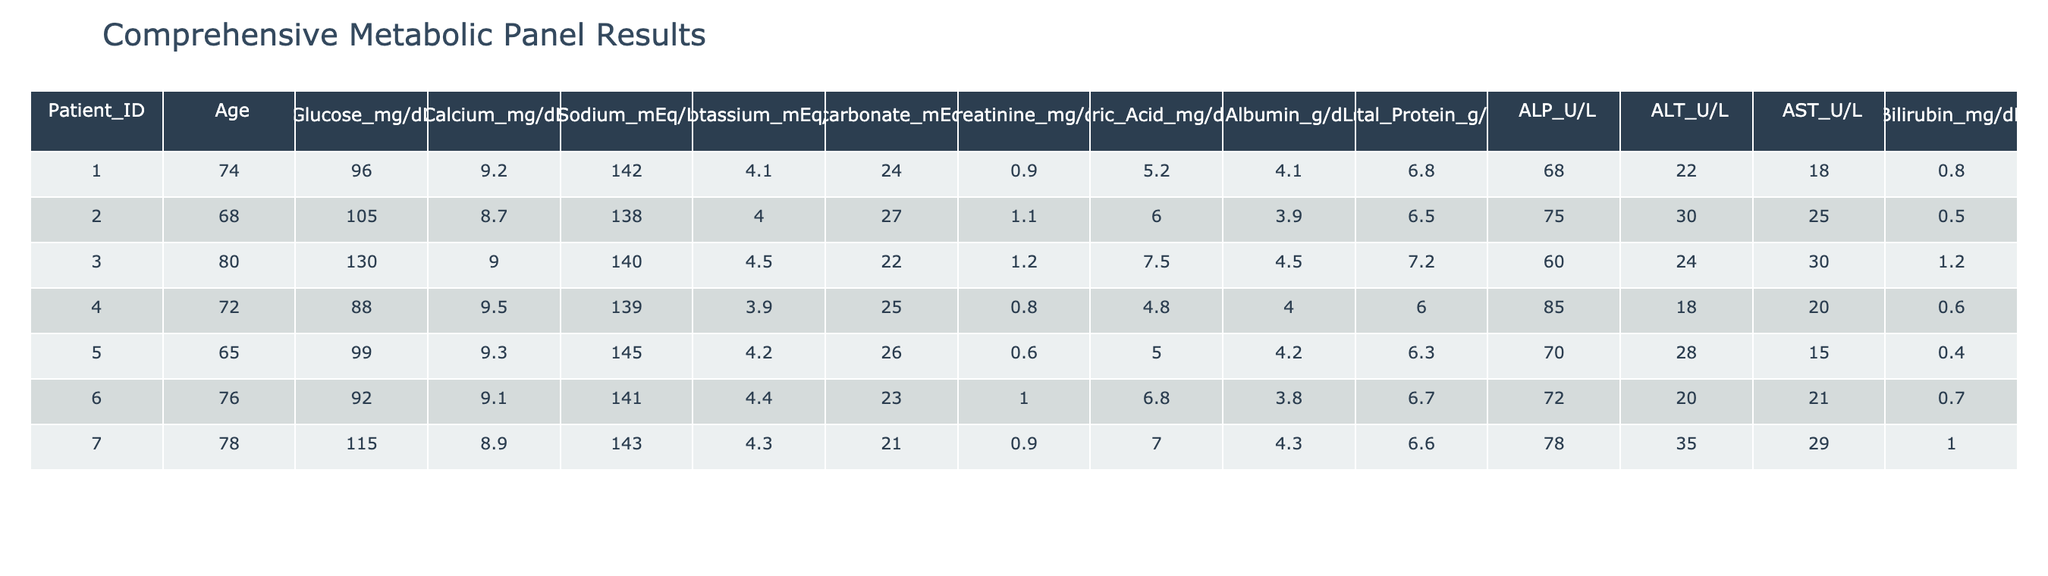What is the glucose level of patient ID 003? By looking at the row corresponding to patient ID 003, we see that the glucose level is listed under the Glucose_mg/dL column. The value there is 130.
Answer: 130 What is the age of the oldest patient in the table? First, we look at the Age column and identify the maximum age by scanning through the values. The highest value is 80, which belongs to patient ID 003.
Answer: 80 Are there any patients with a potassium level greater than 4.5 mEq/L? We need to check the Potassium_mEq/L column for values exceeding 4.5. Scanning through the data, patients ID 007 (4.3) and ID 003 (4.5) do not exceed this value. Therefore, there are no patients with potassium levels greater than 4.5.
Answer: No What is the average creatinine level for the patients listed? We sum the creatinine values (0.9 + 1.1 + 1.2 + 0.8 + 0.6 + 0.9 + 1.0) = 6.5. There are 7 patients, so we divide 6.5 by 7 to get the average. The calculation results in approximately 0.93.
Answer: 0.93 Which patient has the highest total protein level? We will check the Total_Protein_g/dL column for the highest value. Scanning the values, we find patient ID 001 has 6.8, and patient ID 002 has 6.5. The highest total protein level is 6.8, from patient ID 001.
Answer: 6.8 What is the difference in bilirubin levels between the highest and lowest in the table? We first identify the maximum (1.2 from patient ID 003) and minimum (0.4 from patient ID 005) bilirubin levels from the Bilirubin_mg/dL column. Their difference is 1.2 - 0.4 = 0.8.
Answer: 0.8 How many patients have an albumin level below 4 g/dL? We look at the Albumin_g/dL column to count how many values fall below 4. Patient IDs 002 (3.9) and ID 006 (3.8) have levels under 4. This shows that there are 2 patients with albumin levels below that threshold.
Answer: 2 Is the sodium level for patient ID 001 above the normal range of 135-145 mEq/L? Looking at patient ID 001's sodium level of 142 in the Sodium_mEq/L column, we can confirm it falls within the normal range of 135-145. Therefore, the statement is true.
Answer: Yes What is the total calcium level of all the patients combined? We sum the calcium levels (9.2 + 8.7 + 9.0 + 9.5 + 9.3 + 9.1 + 8.9) = 63.7. This gives us the total calcium level for all patients.
Answer: 63.7 